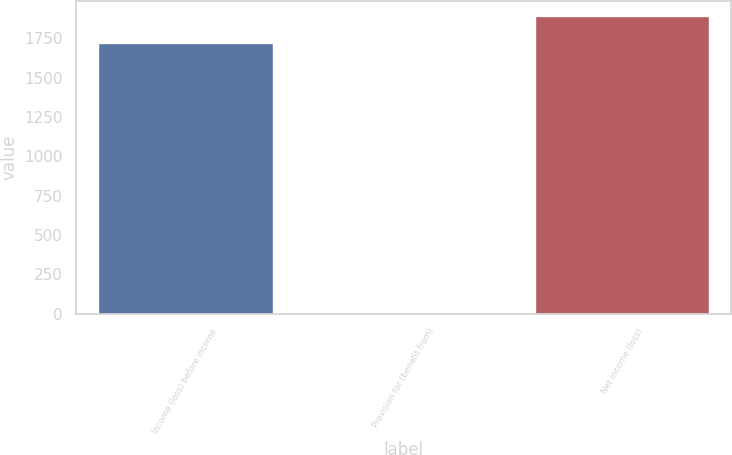Convert chart to OTSL. <chart><loc_0><loc_0><loc_500><loc_500><bar_chart><fcel>Income (loss) before income<fcel>Provision for (benefit from)<fcel>Net income (loss)<nl><fcel>1721.2<fcel>4.8<fcel>1893.32<nl></chart> 